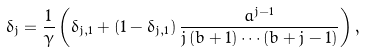<formula> <loc_0><loc_0><loc_500><loc_500>\delta _ { j } = \frac { 1 } { \gamma } \left ( \delta _ { j , 1 } + ( 1 - \delta _ { j , 1 } ) \, \frac { a ^ { j - 1 } } { j \, ( b + 1 ) \cdots ( b + j - 1 ) } \right ) ,</formula> 